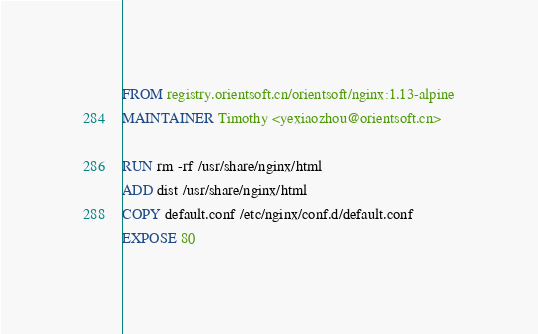<code> <loc_0><loc_0><loc_500><loc_500><_Dockerfile_>FROM registry.orientsoft.cn/orientsoft/nginx:1.13-alpine
MAINTAINER Timothy <yexiaozhou@orientsoft.cn>

RUN rm -rf /usr/share/nginx/html
ADD dist /usr/share/nginx/html
COPY default.conf /etc/nginx/conf.d/default.conf
EXPOSE 80
</code> 